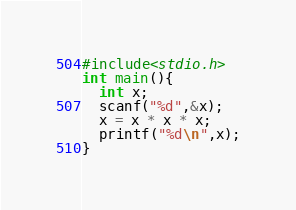<code> <loc_0><loc_0><loc_500><loc_500><_C_>#include<stdio.h>
int main(){
  int x;
  scanf("%d",&x);
  x = x * x * x;
  printf("%d\n",x);
}</code> 